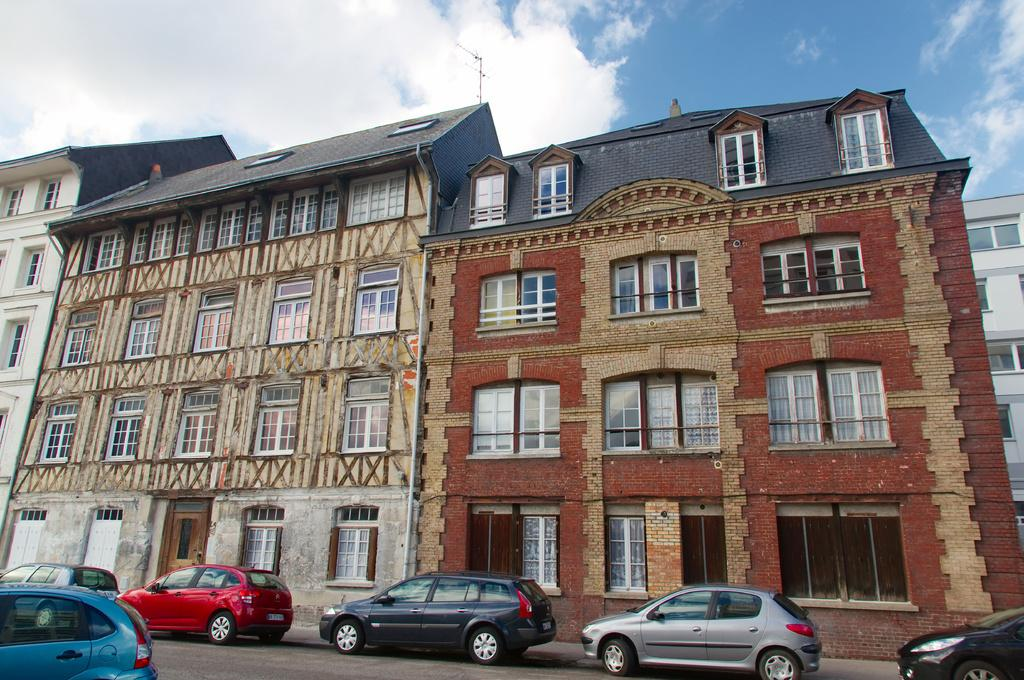What type of structures can be seen in the image? There are buildings in the image. What feature is visible on the buildings? There are windows visible in the image. What type of transportation is present on the road in the image? There are vehicles on the road in the image. What part of the natural environment is visible in the image? The sky is visible in the image. What can be observed in the sky? Clouds are present in the sky. What type of rice can be seen in the image? There is no rice present in the image. What is the hope doing in the image? There is no hope depicted in the image; it is an abstract concept and not a visual element. 